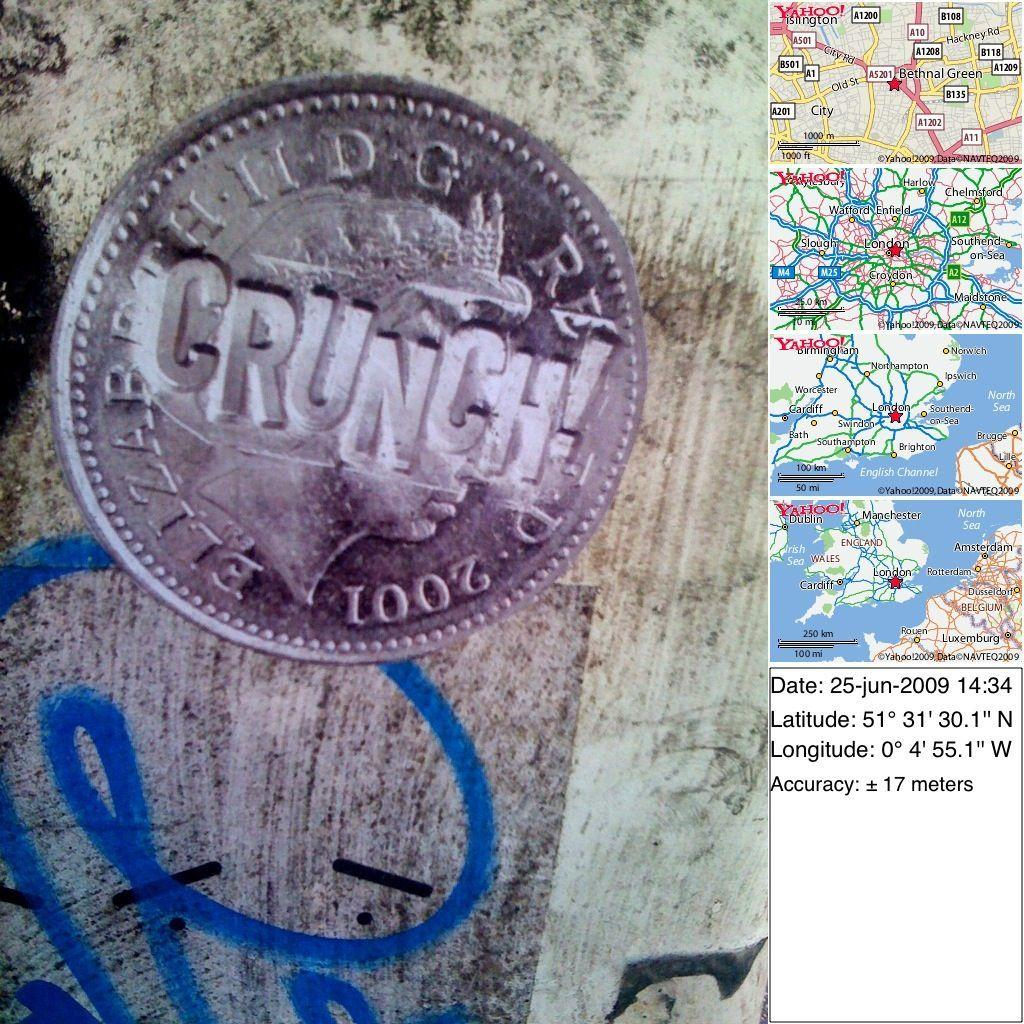<image>
Offer a succinct explanation of the picture presented. A Crunch coin that is next to a map showing cities like Ipswich. 